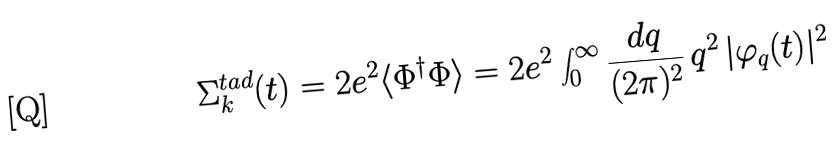Convert formula to latex. <formula><loc_0><loc_0><loc_500><loc_500>\Sigma _ { k } ^ { t a d } ( t ) = 2 e ^ { 2 } \langle \Phi ^ { \dagger } \Phi \rangle = 2 e ^ { 2 } \int _ { 0 } ^ { \infty } \frac { d q } { ( 2 \pi ) ^ { 2 } } \, q ^ { 2 } \, | \varphi _ { q } ( t ) | ^ { 2 }</formula> 